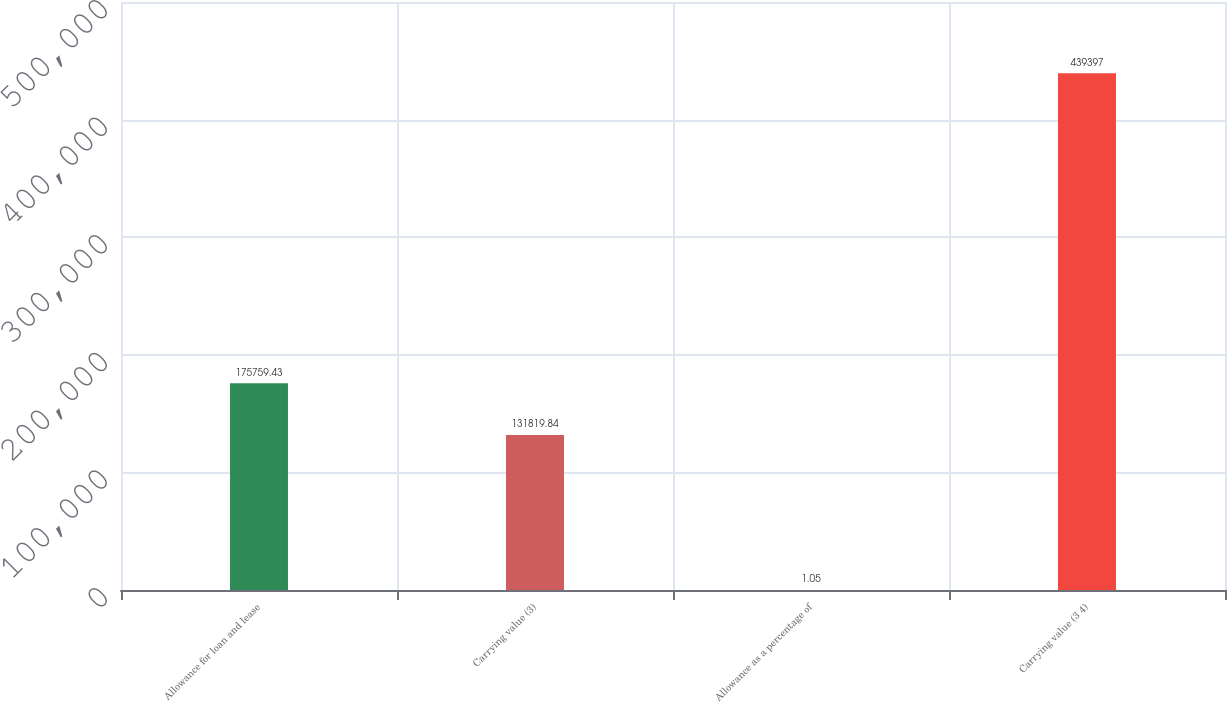Convert chart. <chart><loc_0><loc_0><loc_500><loc_500><bar_chart><fcel>Allowance for loan and lease<fcel>Carrying value (3)<fcel>Allowance as a percentage of<fcel>Carrying value (3 4)<nl><fcel>175759<fcel>131820<fcel>1.05<fcel>439397<nl></chart> 